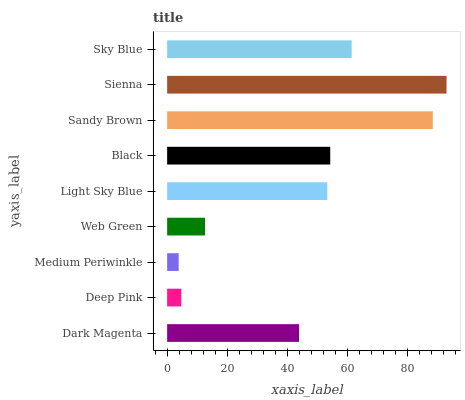Is Medium Periwinkle the minimum?
Answer yes or no. Yes. Is Sienna the maximum?
Answer yes or no. Yes. Is Deep Pink the minimum?
Answer yes or no. No. Is Deep Pink the maximum?
Answer yes or no. No. Is Dark Magenta greater than Deep Pink?
Answer yes or no. Yes. Is Deep Pink less than Dark Magenta?
Answer yes or no. Yes. Is Deep Pink greater than Dark Magenta?
Answer yes or no. No. Is Dark Magenta less than Deep Pink?
Answer yes or no. No. Is Light Sky Blue the high median?
Answer yes or no. Yes. Is Light Sky Blue the low median?
Answer yes or no. Yes. Is Dark Magenta the high median?
Answer yes or no. No. Is Sky Blue the low median?
Answer yes or no. No. 